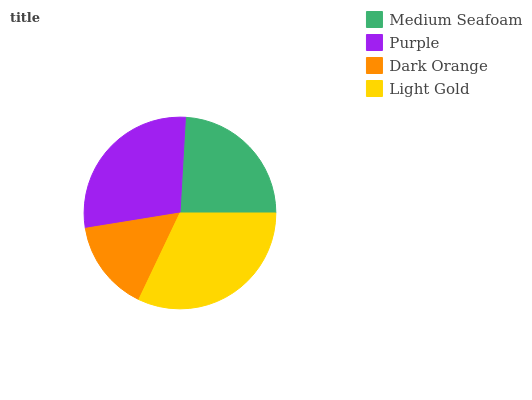Is Dark Orange the minimum?
Answer yes or no. Yes. Is Light Gold the maximum?
Answer yes or no. Yes. Is Purple the minimum?
Answer yes or no. No. Is Purple the maximum?
Answer yes or no. No. Is Purple greater than Medium Seafoam?
Answer yes or no. Yes. Is Medium Seafoam less than Purple?
Answer yes or no. Yes. Is Medium Seafoam greater than Purple?
Answer yes or no. No. Is Purple less than Medium Seafoam?
Answer yes or no. No. Is Purple the high median?
Answer yes or no. Yes. Is Medium Seafoam the low median?
Answer yes or no. Yes. Is Medium Seafoam the high median?
Answer yes or no. No. Is Light Gold the low median?
Answer yes or no. No. 